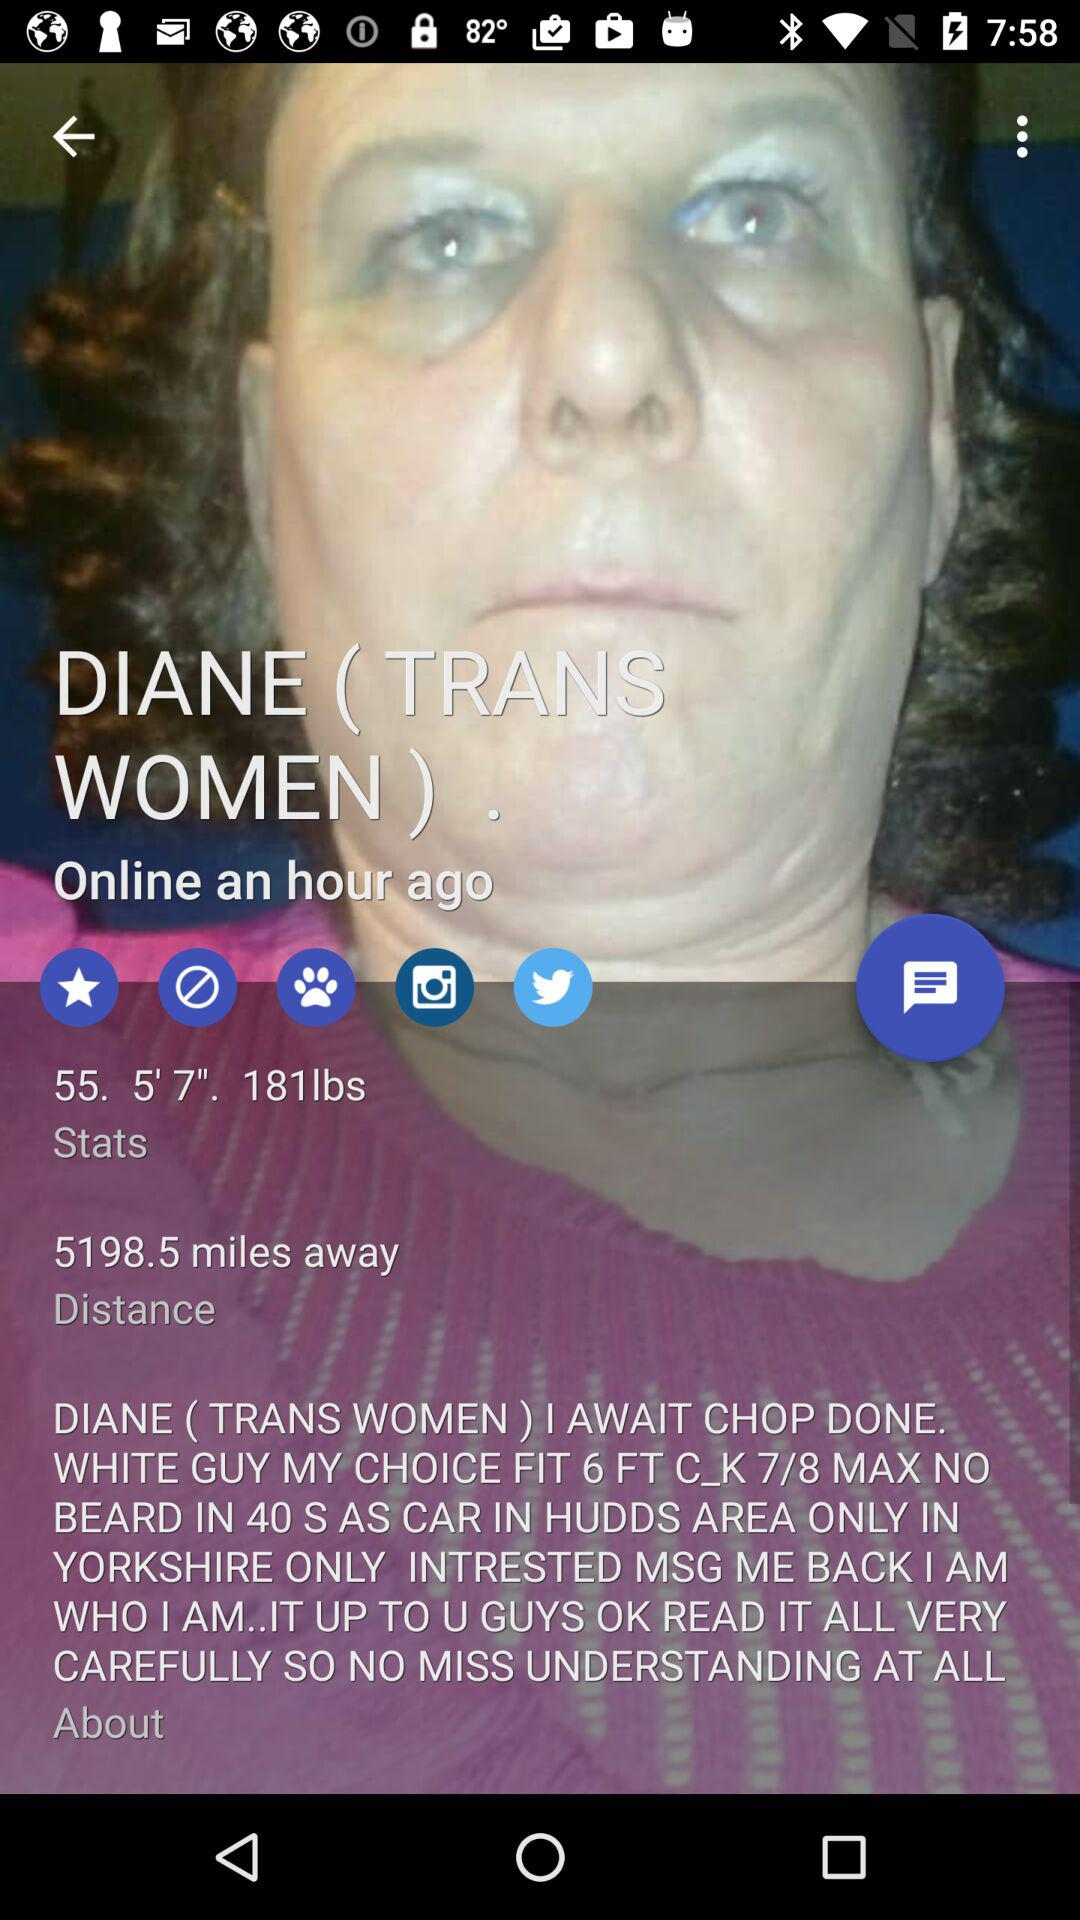How many miles is Diane away?
Answer the question using a single word or phrase. 5198.5 